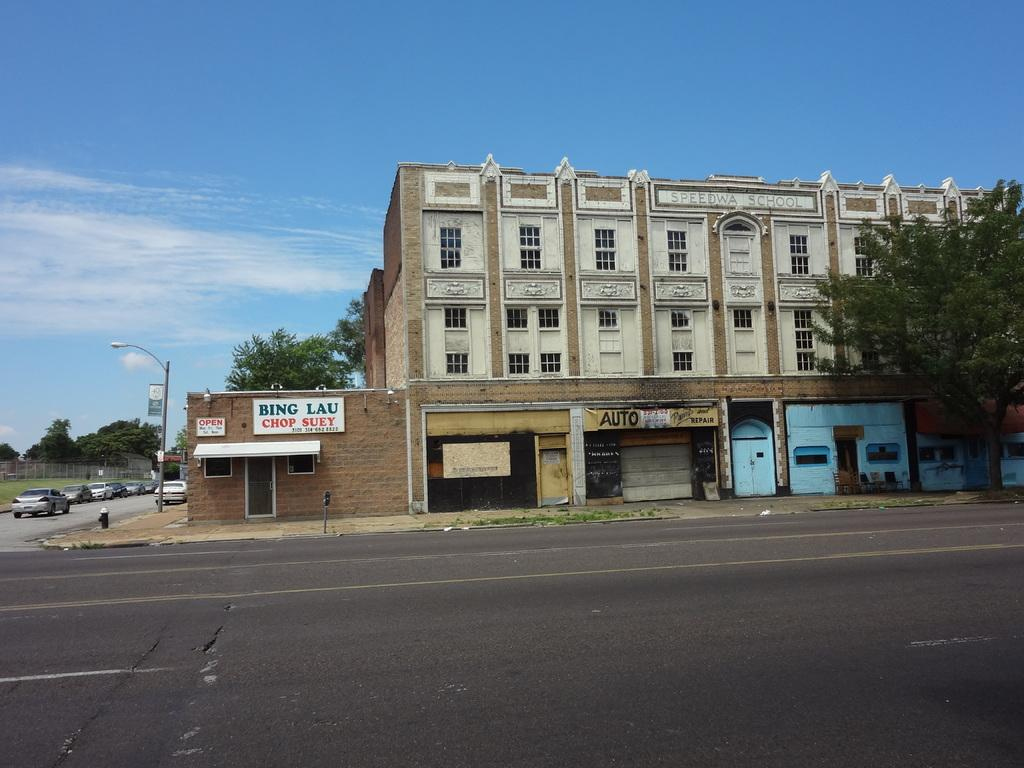What is located in the foreground of the image? There is a road in the foreground of the image. What can be seen in the middle of the image? There is a building, trees, a street light, and cars in the middle of the image. What is visible at the top of the image? The sky is visible at the top of the image. Is there any quicksand visible in the image? No, there is no quicksand present in the image. What type of line is drawn across the middle of the image? There is no line drawn across the middle of the image; it is a street with cars, trees, and a building. 